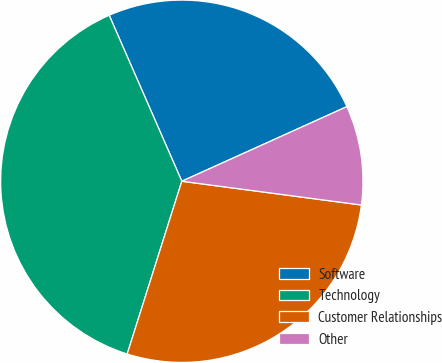Convert chart to OTSL. <chart><loc_0><loc_0><loc_500><loc_500><pie_chart><fcel>Software<fcel>Technology<fcel>Customer Relationships<fcel>Other<nl><fcel>24.81%<fcel>38.56%<fcel>27.78%<fcel>8.85%<nl></chart> 